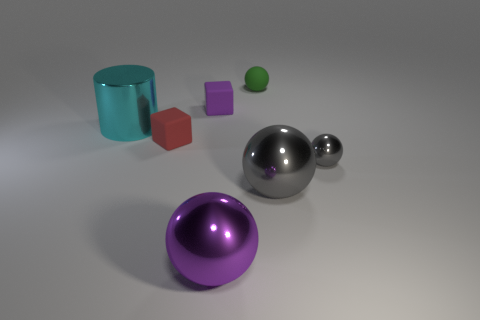Add 1 tiny red rubber blocks. How many objects exist? 8 Subtract all red blocks. How many blocks are left? 1 Subtract all metal spheres. How many spheres are left? 1 Subtract 1 spheres. How many spheres are left? 3 Subtract all cylinders. How many objects are left? 6 Subtract all cyan spheres. Subtract all blue cubes. How many spheres are left? 4 Subtract all yellow balls. How many purple cubes are left? 1 Subtract all cyan matte blocks. Subtract all gray shiny spheres. How many objects are left? 5 Add 5 red matte things. How many red matte things are left? 6 Add 4 blocks. How many blocks exist? 6 